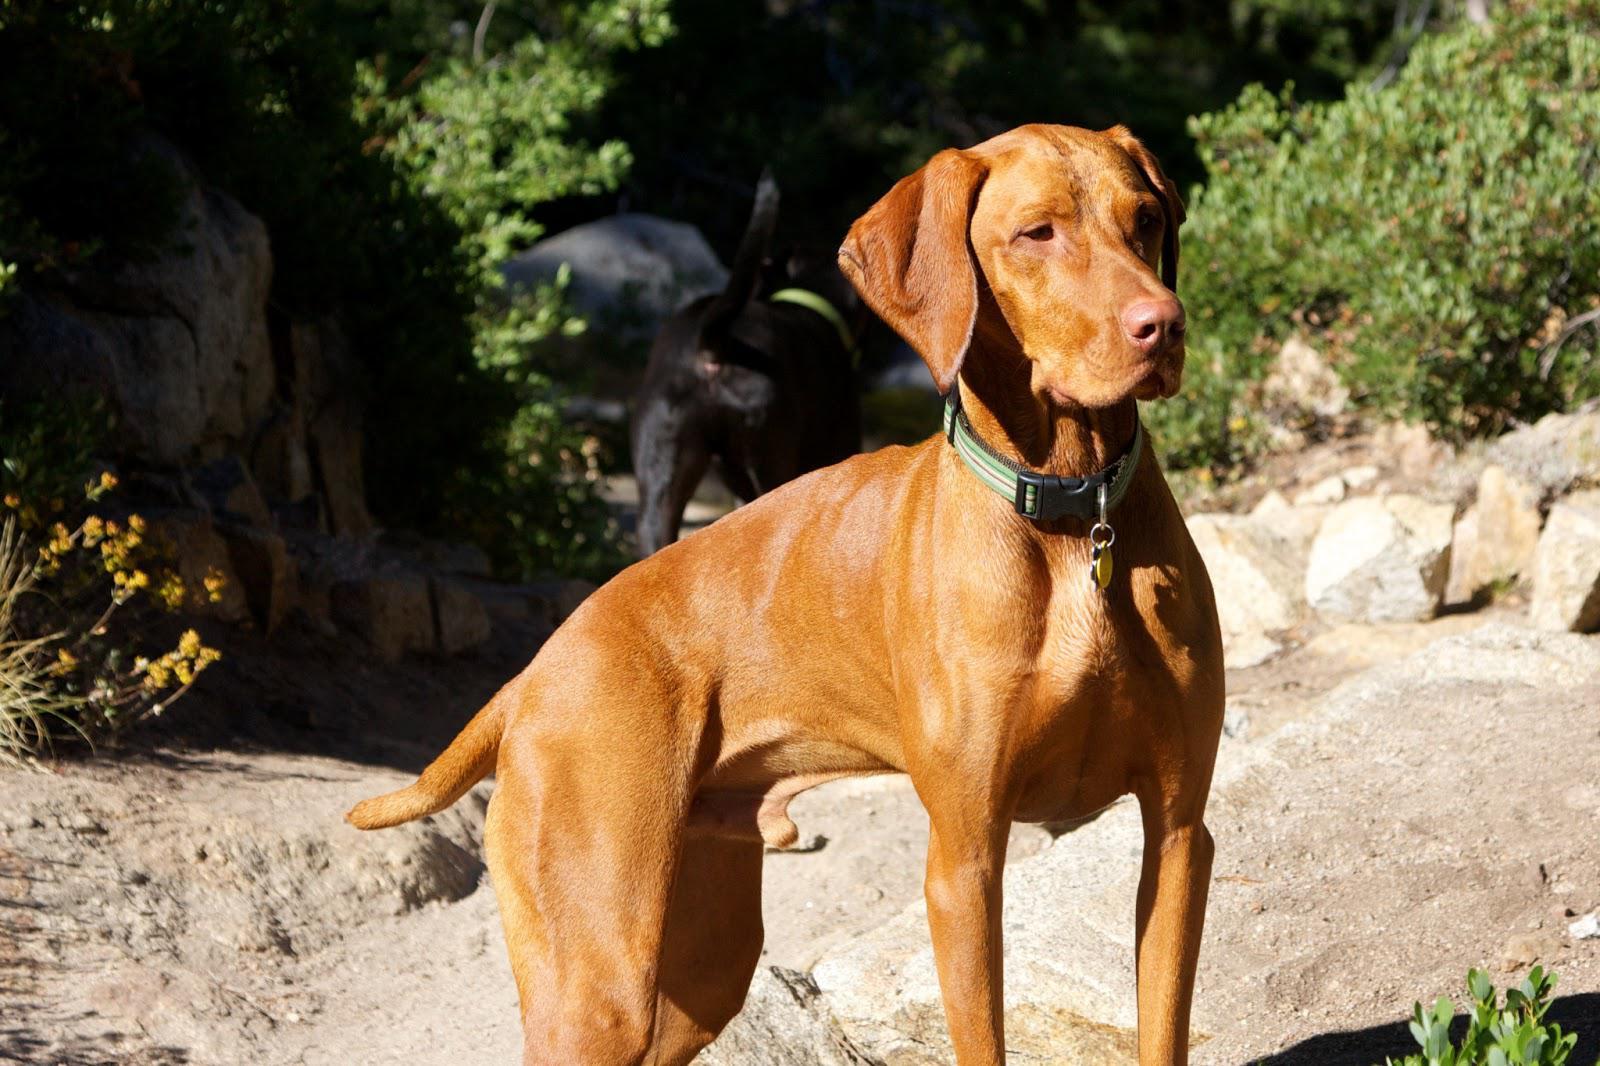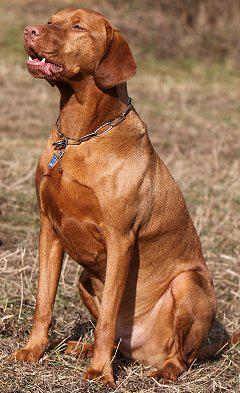The first image is the image on the left, the second image is the image on the right. Evaluate the accuracy of this statement regarding the images: "All of the brown dogs are wearing collars.". Is it true? Answer yes or no. Yes. The first image is the image on the left, the second image is the image on the right. Given the left and right images, does the statement "There are only two dogs in the pair of images." hold true? Answer yes or no. Yes. 